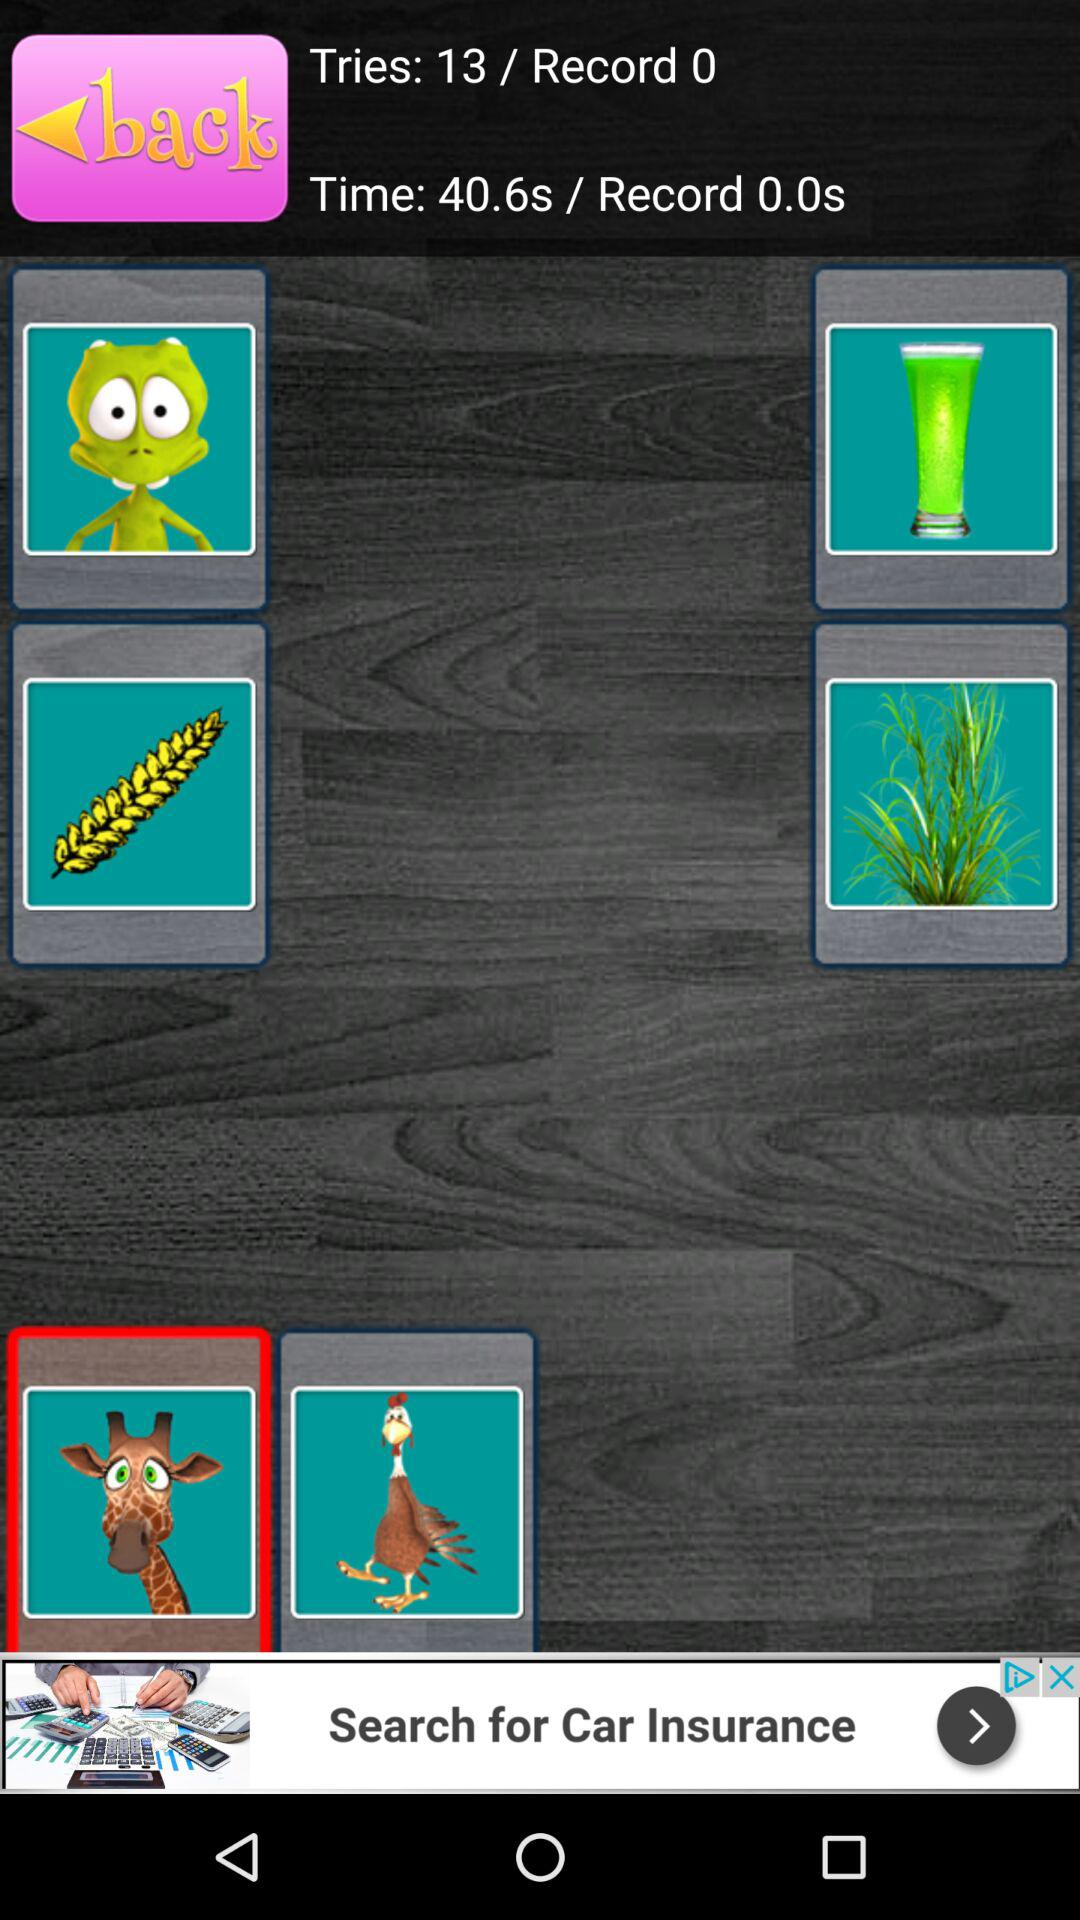How much time has been elapsed? The elapsed time is 40.6 seconds. 